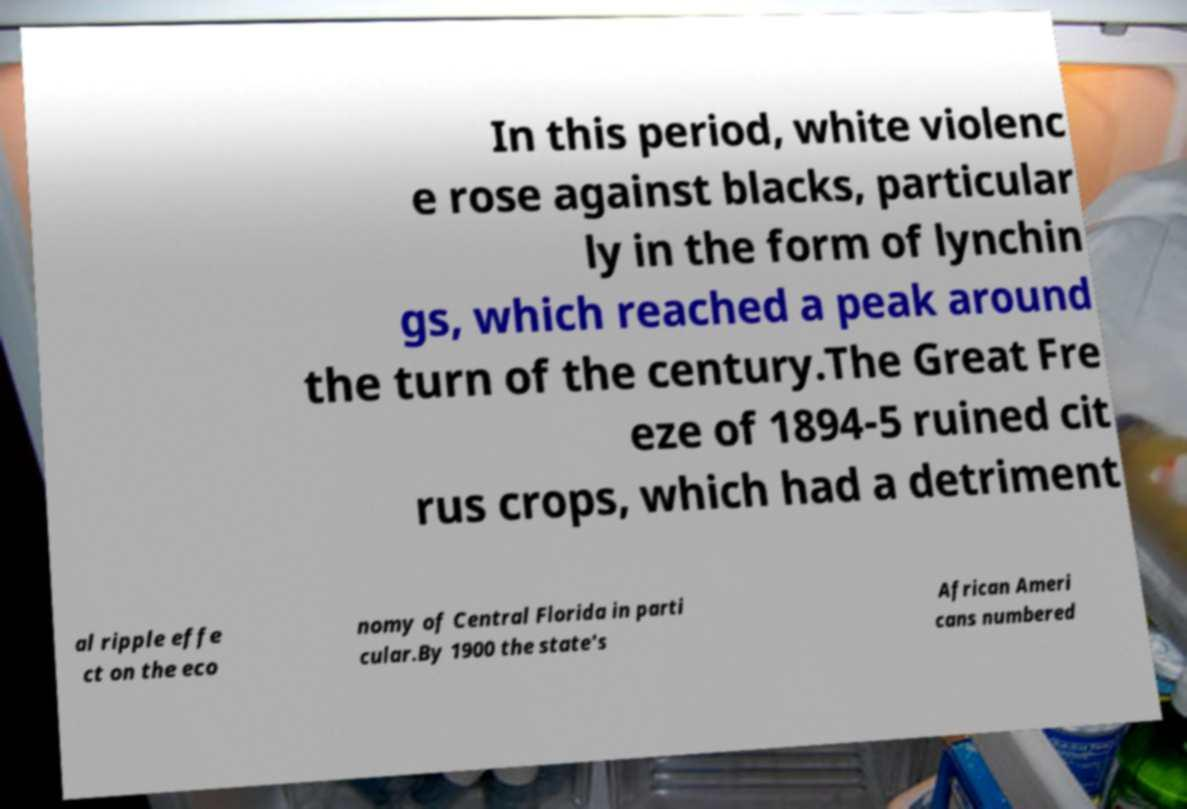Can you accurately transcribe the text from the provided image for me? In this period, white violenc e rose against blacks, particular ly in the form of lynchin gs, which reached a peak around the turn of the century.The Great Fre eze of 1894-5 ruined cit rus crops, which had a detriment al ripple effe ct on the eco nomy of Central Florida in parti cular.By 1900 the state's African Ameri cans numbered 